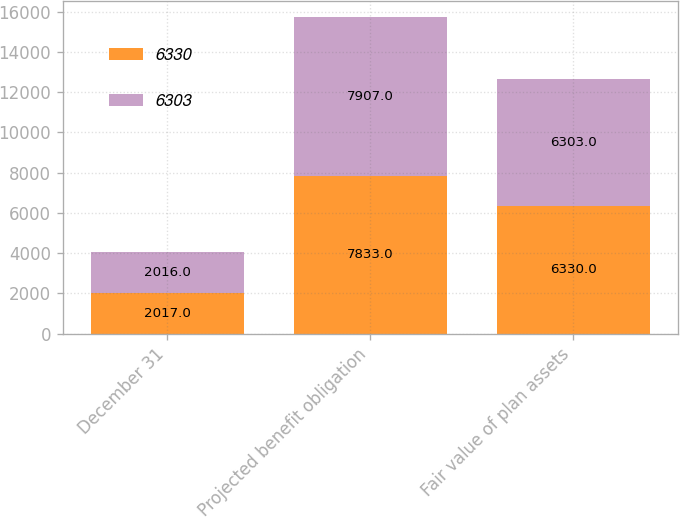<chart> <loc_0><loc_0><loc_500><loc_500><stacked_bar_chart><ecel><fcel>December 31<fcel>Projected benefit obligation<fcel>Fair value of plan assets<nl><fcel>6330<fcel>2017<fcel>7833<fcel>6330<nl><fcel>6303<fcel>2016<fcel>7907<fcel>6303<nl></chart> 